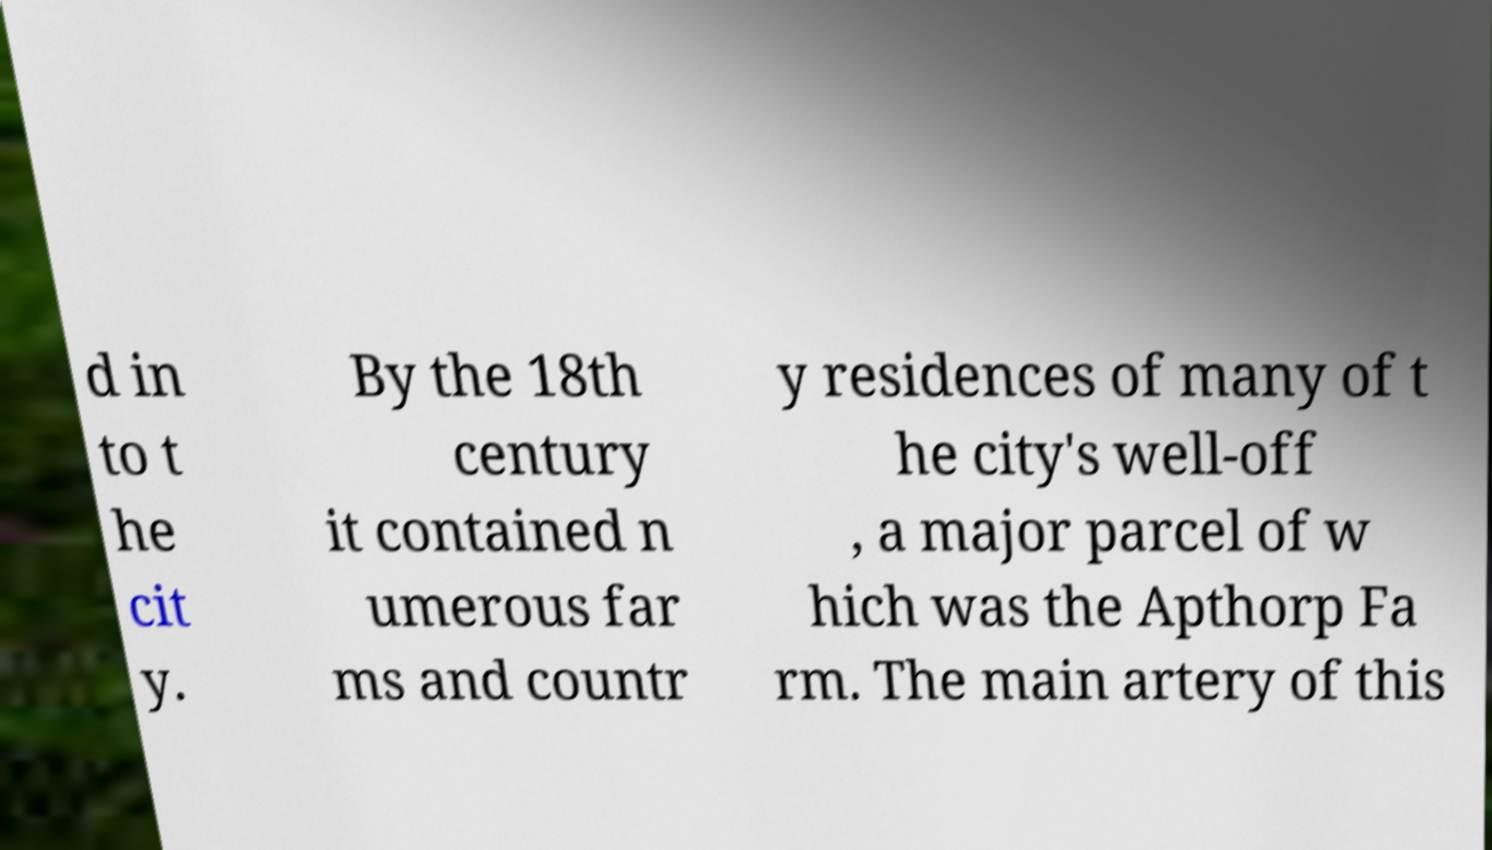Can you read and provide the text displayed in the image?This photo seems to have some interesting text. Can you extract and type it out for me? d in to t he cit y. By the 18th century it contained n umerous far ms and countr y residences of many of t he city's well-off , a major parcel of w hich was the Apthorp Fa rm. The main artery of this 